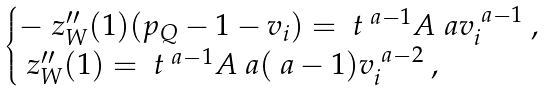<formula> <loc_0><loc_0><loc_500><loc_500>\begin{cases} - \ z _ { W } ^ { \prime \prime } ( 1 ) ( p _ { Q } - 1 - v _ { i } ) = \ t ^ { \ a - 1 } A \ a v _ { i } ^ { \ a - 1 } \ , \\ \ z _ { W } ^ { \prime \prime } ( 1 ) = \ t ^ { \ a - 1 } A \ a ( \ a - 1 ) v _ { i } ^ { \ a - 2 } \ , \end{cases}</formula> 